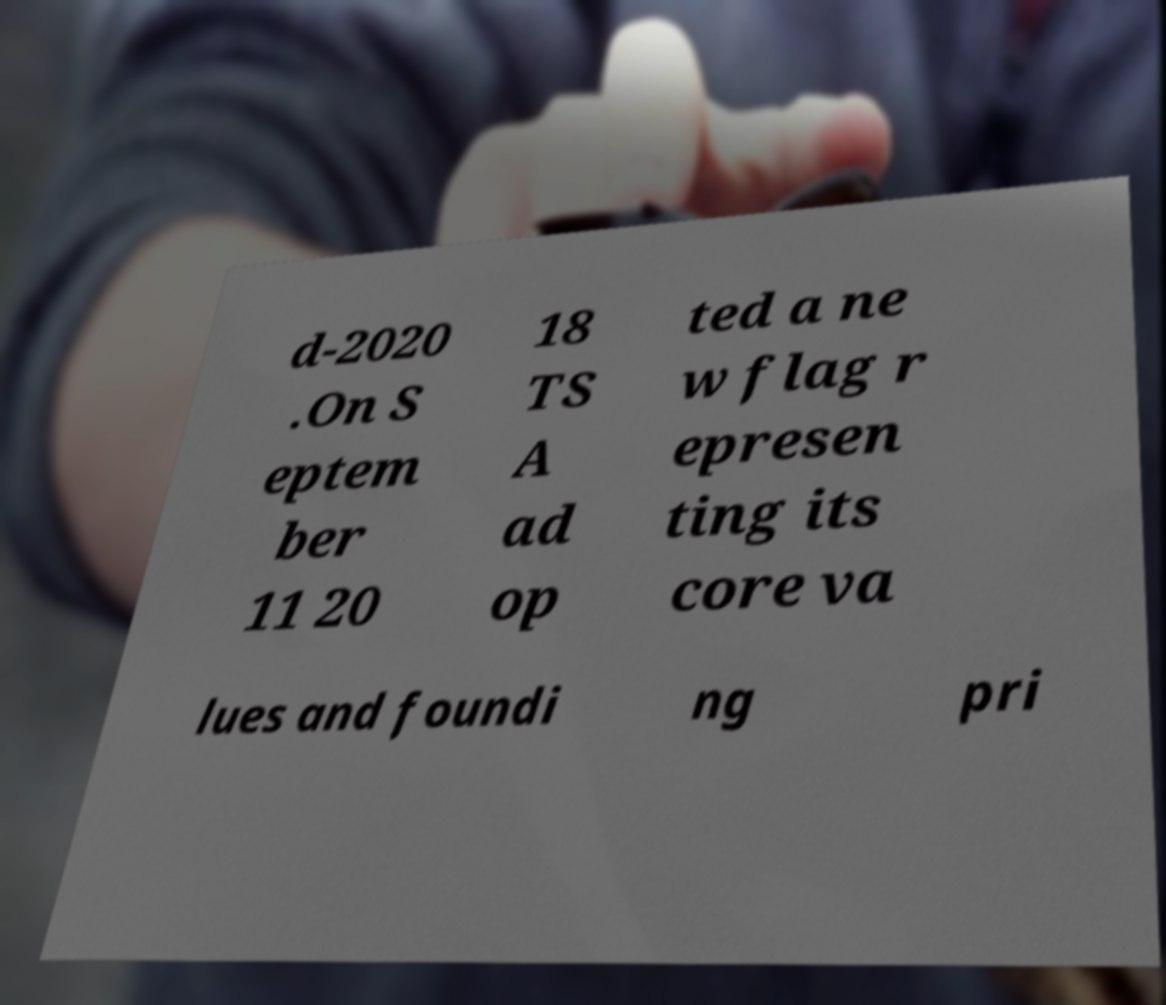What messages or text are displayed in this image? I need them in a readable, typed format. d-2020 .On S eptem ber 11 20 18 TS A ad op ted a ne w flag r epresen ting its core va lues and foundi ng pri 